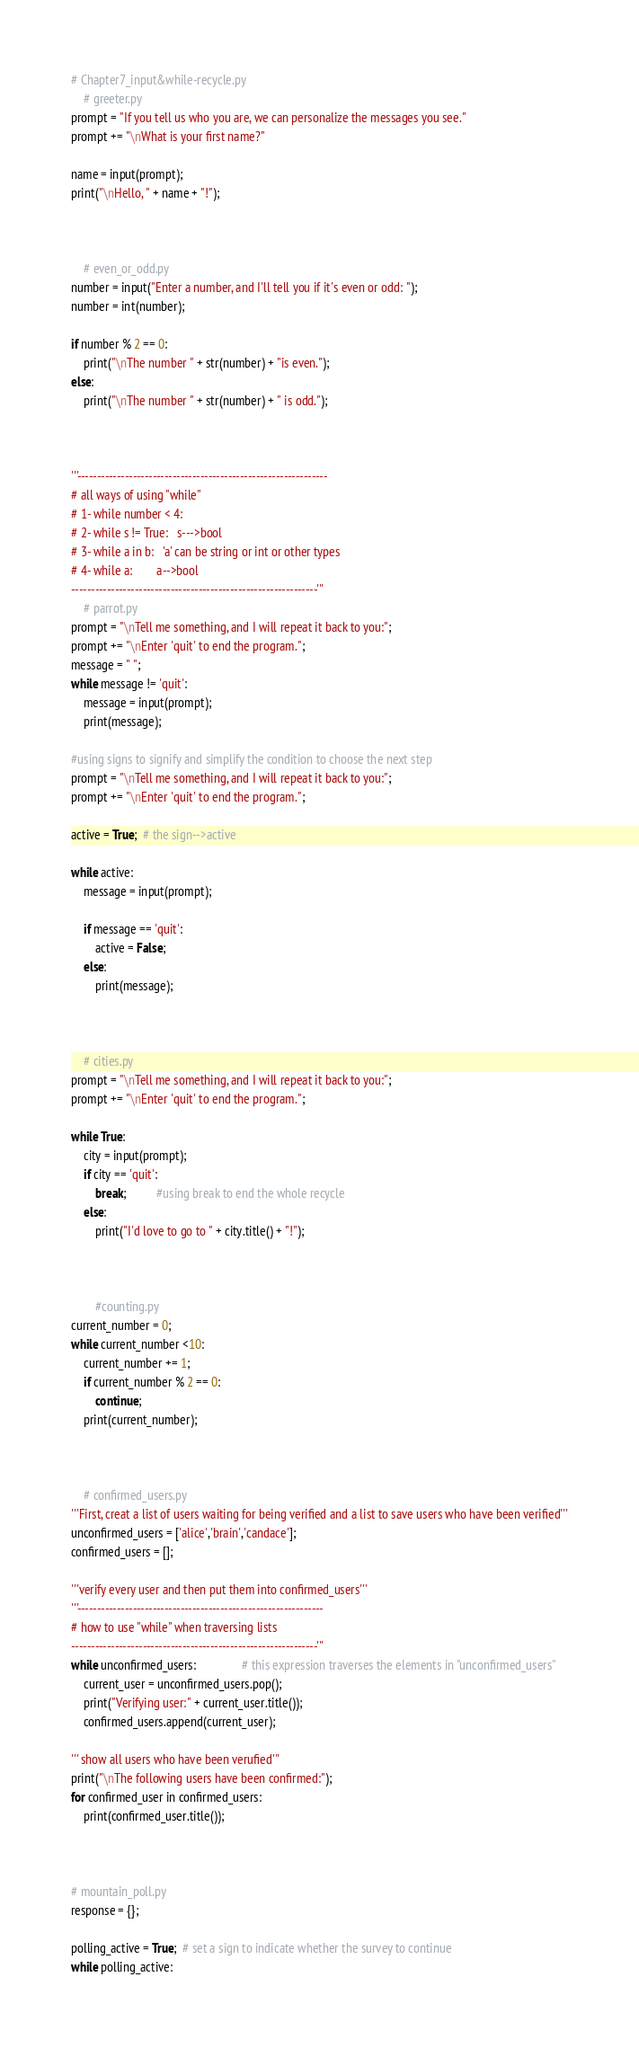Convert code to text. <code><loc_0><loc_0><loc_500><loc_500><_Python_># Chapter7_input&while-recycle.py
    # greeter.py
prompt = "If you tell us who you are, we can personalize the messages you see."
prompt += "\nWhat is your first name?"

name = input(prompt);
print("\nHello, " + name + "!");



    # even_or_odd.py
number = input("Enter a number, and I'll tell you if it's even or odd: ");
number = int(number);

if number % 2 == 0:
    print("\nThe number " + str(number) + "is even.");
else:
    print("\nThe number " + str(number) + " is odd.");



'''---------------------------------------------------------------
# all ways of using "while"
# 1- while number < 4:
# 2- while s != True:   s--->bool
# 3- while a in b:   'a' can be string or int or other types
# 4- while a:        a-->bool
--------------------------------------------------------------'''
    # parrot.py
prompt = "\nTell me something, and I will repeat it back to you:";
prompt += "\nEnter 'quit' to end the program.";
message = " ";
while message != 'quit':
    message = input(prompt);
    print(message);

#using signs to signify and simplify the condition to choose the next step
prompt = "\nTell me something, and I will repeat it back to you:";
prompt += "\nEnter 'quit' to end the program.";

active = True;  # the sign-->active

while active:
    message = input(prompt);

    if message == 'quit':
        active = False;
    else:
        print(message);



    # cities.py
prompt = "\nTell me something, and I will repeat it back to you:";
prompt += "\nEnter 'quit' to end the program.";

while True:
    city = input(prompt);
    if city == 'quit':
        break;          #using break to end the whole recycle
    else:
        print("I'd love to go to " + city.title() + "!");



        #counting.py
current_number = 0;
while current_number <10:
    current_number += 1;
    if current_number % 2 == 0:
        continue;
    print(current_number);



    # confirmed_users.py
'''First, creat a list of users waiting for being verified and a list to save users who have been verified'''
unconfirmed_users = ['alice','brain','candace'];
confirmed_users = [];

'''verify every user and then put them into confirmed_users'''
'''--------------------------------------------------------------
# how to use "while" when traversing lists
--------------------------------------------------------------'''
while unconfirmed_users:               # this expression traverses the elements in "unconfirmed_users"
    current_user = unconfirmed_users.pop();
    print("Verifying user:" + current_user.title());
    confirmed_users.append(current_user);

''' show all users who have been verufied'''
print("\nThe following users have been confirmed:");
for confirmed_user in confirmed_users:
    print(confirmed_user.title());



# mountain_poll.py
response = {};

polling_active = True;  # set a sign to indicate whether the survey to continue
while polling_active:</code> 